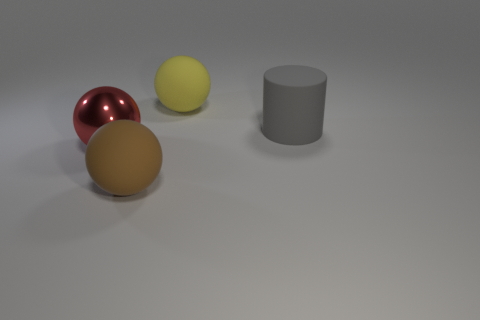Subtract all metallic spheres. How many spheres are left? 2 Add 3 cylinders. How many objects exist? 7 Subtract all spheres. How many objects are left? 1 Subtract all red balls. Subtract all purple cylinders. How many balls are left? 2 Subtract all green cylinders. How many yellow balls are left? 1 Subtract all big brown matte things. Subtract all small cyan rubber things. How many objects are left? 3 Add 3 gray rubber things. How many gray rubber things are left? 4 Add 1 large red balls. How many large red balls exist? 2 Subtract 0 blue spheres. How many objects are left? 4 